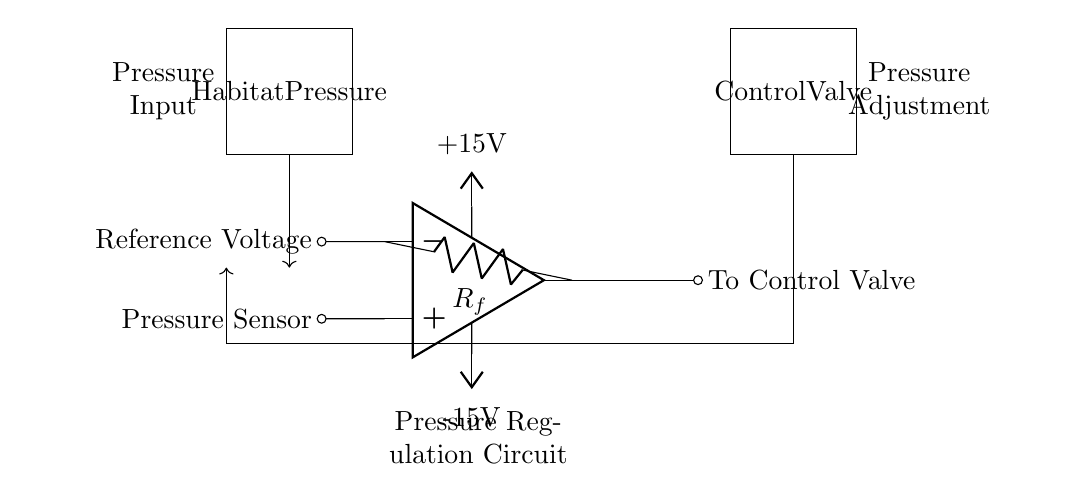What component provides the pressure input? The pressure input in the circuit is provided by the Pressure Sensor, which is indicated on the left side of the diagram.
Answer: Pressure Sensor What is the function of the feedback resistor? The feedback resistor, denoted as R_f, is part of a feedback loop that helps regulate the output based on the difference between the input pressure and the reference voltage.
Answer: Regulate output What are the power supply voltages in the circuit? The circuit uses a dual power supply with +15V and -15V as indicated next to the op-amp, providing the necessary voltage levels for operation.
Answer: +15V and -15V What type of control is implemented by this circuit? The circuit implements feedback control, where the output is adjusted based on the feedback from the habitat's pressure to maintain a desired set point.
Answer: Feedback control How is the pressure regulation achieved? Pressure regulation is achieved through the comparison of the pressure sensor signal with a reference voltage in the op-amp, which then adjusts the control valve to maintain the desired pressure in the habitat.
Answer: Through op-amp and control valve What would happen if the pressure sensor fails? If the pressure sensor fails, the op-amp would not receive accurate feedback about the habitat pressure, potentially leading to incorrect adjustments by the control valve, which could jeopardize habitat conditions.
Answer: Incorrect adjustments 